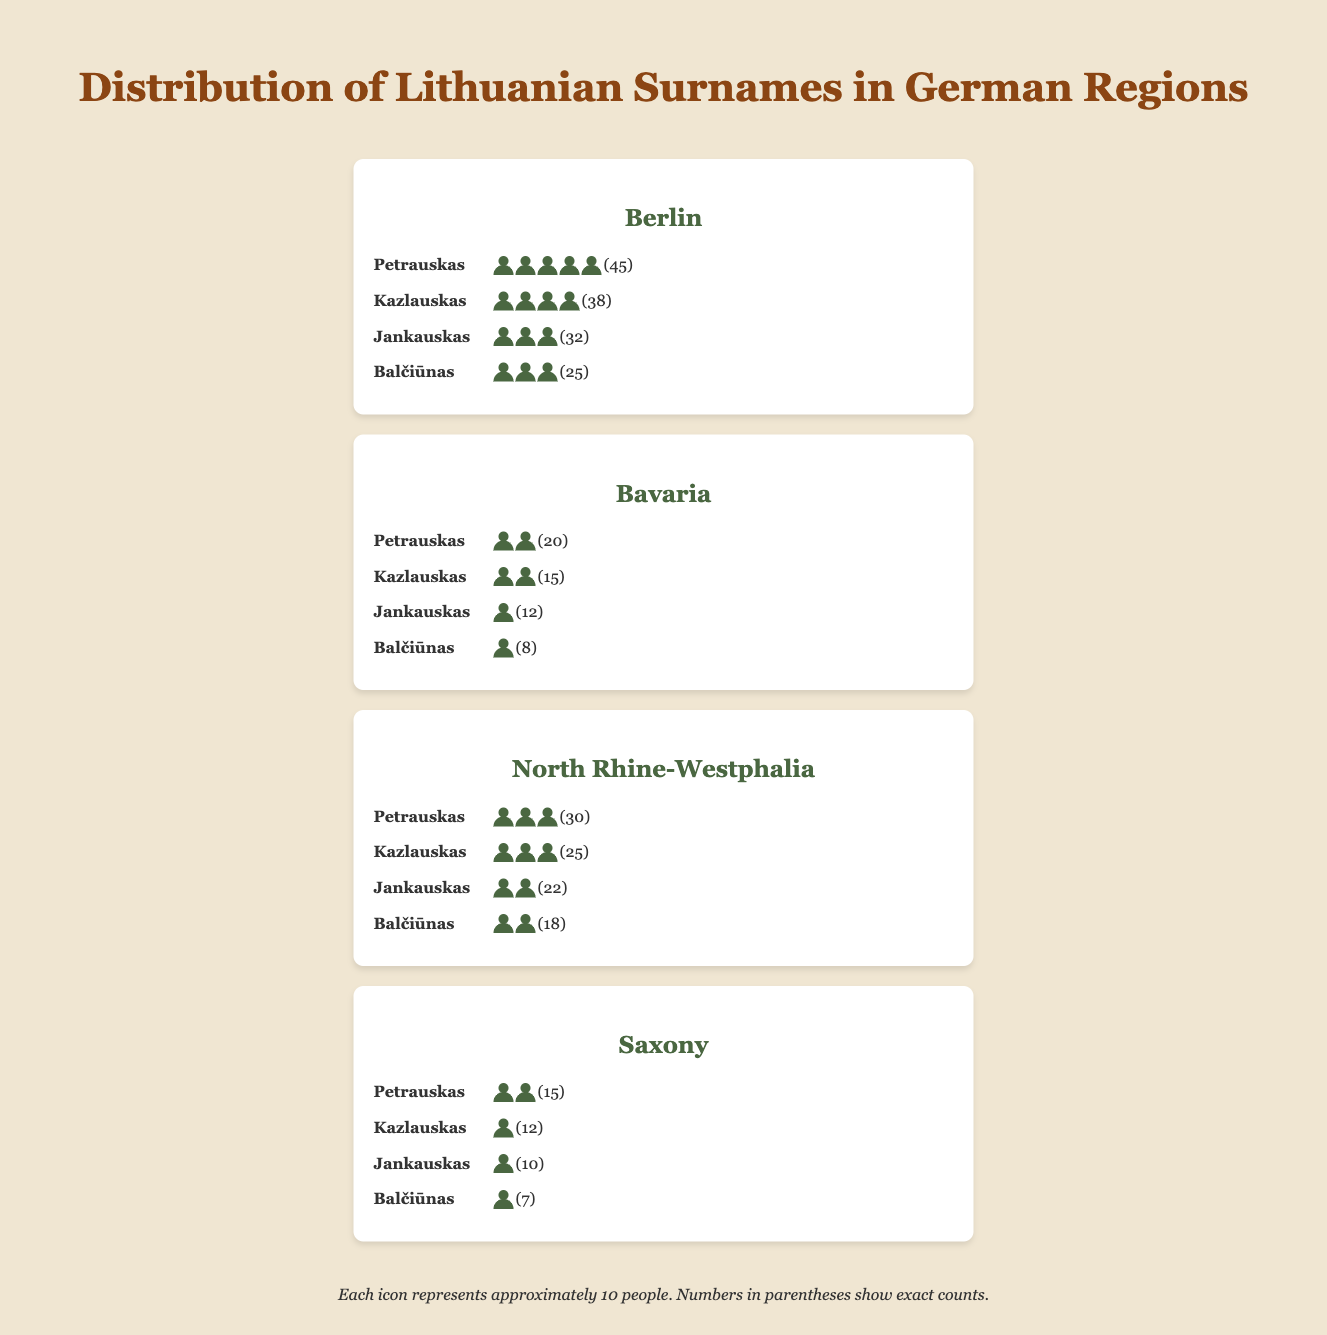What is the title of the figure? The title appears at the top of the figure, centrally aligned, and clearly indicates what the figure is about. It reads "Distribution of Lithuanian Surnames in German Regions."
Answer: Distribution of Lithuanian Surnames in German Regions How many regions are displayed in the figure? By visually counting the distinct sections labeled with region names, you can see there are four regions: Berlin, Bavaria, North Rhine-Westphalia, and Saxony.
Answer: Four Which surname has the highest count in Berlin according to the plot? Look at the Berlin section and identify the surname with the most person icons and highest numerical value. "Petrauskas" has 45, which is the highest count.
Answer: Petrauskas What is the total count of the surname 'Balčiūnas' across all regions? Add up the counts in all four regions for 'Balčiūnas': (25 in Berlin) + (8 in Bavaria) + (18 in North Rhine-Westphalia) + (7 in Saxony). The total is 58.
Answer: 58 Between which two regions is the count of 'Kazlauskas' closest? Compare the surname 'Kazlauskas' counts across all regions. The counts are: Berlin (38), Bavaria (15), North Rhine-Westphalia (25), and Saxony (12). The closest counts are Bavaria (15) and Saxony (12), with a difference of 3.
Answer: Bavaria and Saxony Which region has the smallest total count of all surnames combined? Add up the counts for each surname in each region and compare. For Berlin: 45 + 38 + 32 + 25 = 140, for Bavaria: 20 + 15 + 12 + 8 = 55, for North Rhine-Westphalia: 30 + 25 + 22 + 18 = 95, for Saxony: 15 + 12 + 10 + 7 = 44. Saxony has the smallest total count with 44.
Answer: Saxony How many person icons represent the surname 'Petrauskas' in North Rhine-Westphalia? In the North Rhine-Westphalia section for 'Petrauskas', there are 3 person icons, each representing approximately 10 persons, indicating 30 persons total.
Answer: 3 icons Which surname shows the largest variation in counts between regions? Calculate the range (max count minus min count) for each surname across all regions. 'Petrauskas': 45-15=30, 'Kazlauskas': 38-12=26, 'Jankauskas': 32-10=22, 'Balčiūnas': 25-7=18. 'Petrauskas' has the largest variation with 30.
Answer: Petrauskas What is the average count of ‘Jankauskas’ across all regions? Sum the counts of 'Jankauskas' in all regions and divide by the number of regions: (32 + 12 + 22 + 10) / 4 = 76 / 4 = 19.
Answer: 19 